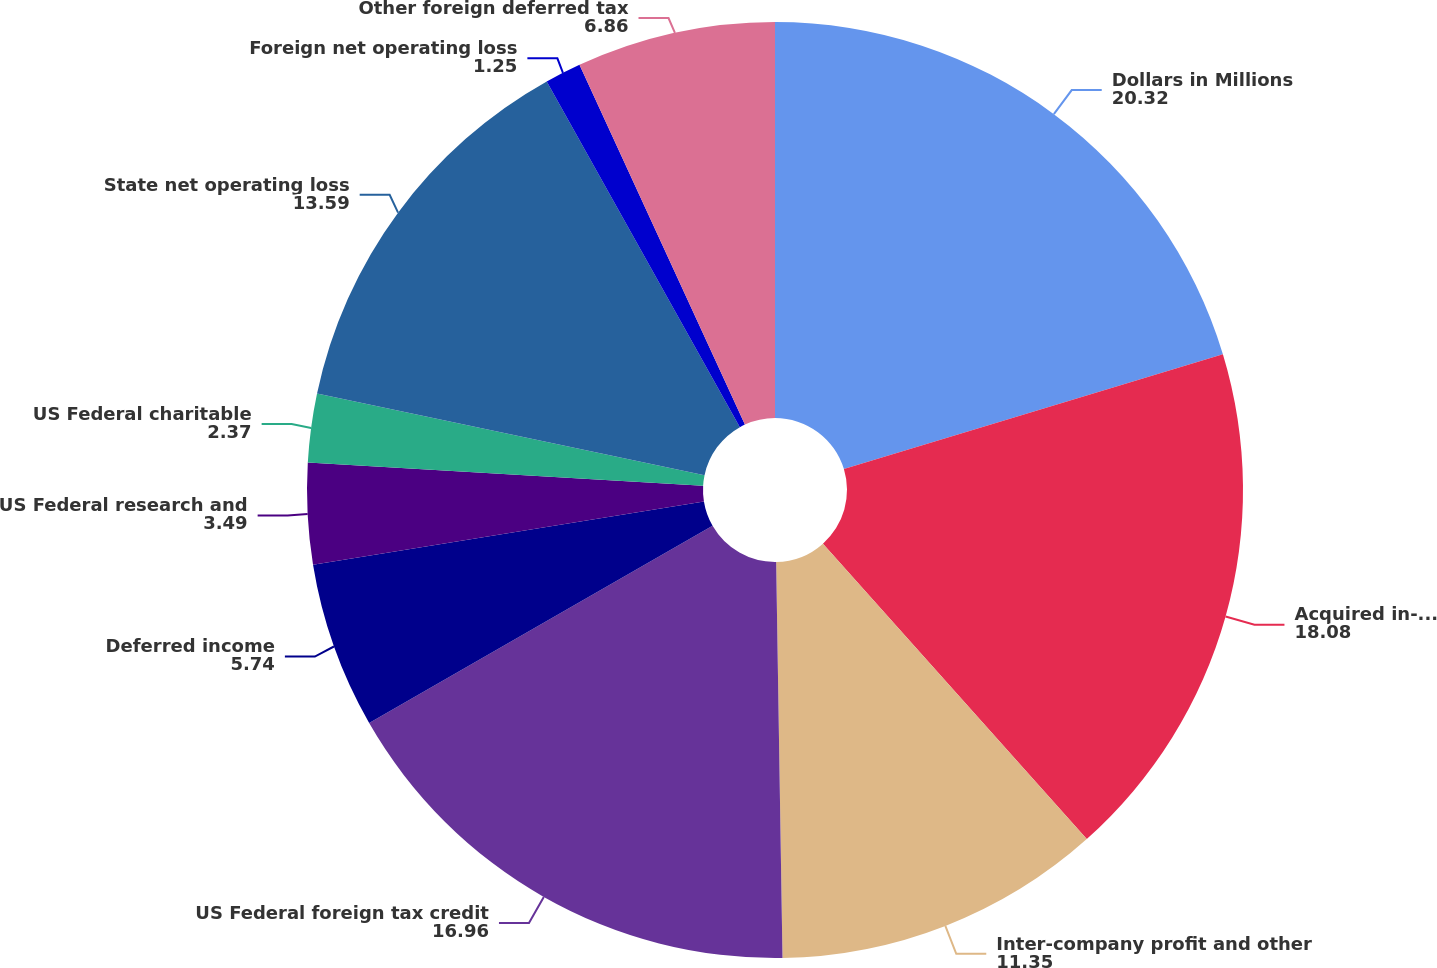<chart> <loc_0><loc_0><loc_500><loc_500><pie_chart><fcel>Dollars in Millions<fcel>Acquired in-process research<fcel>Inter-company profit and other<fcel>US Federal foreign tax credit<fcel>Deferred income<fcel>US Federal research and<fcel>US Federal charitable<fcel>State net operating loss<fcel>Foreign net operating loss<fcel>Other foreign deferred tax<nl><fcel>20.32%<fcel>18.08%<fcel>11.35%<fcel>16.96%<fcel>5.74%<fcel>3.49%<fcel>2.37%<fcel>13.59%<fcel>1.25%<fcel>6.86%<nl></chart> 